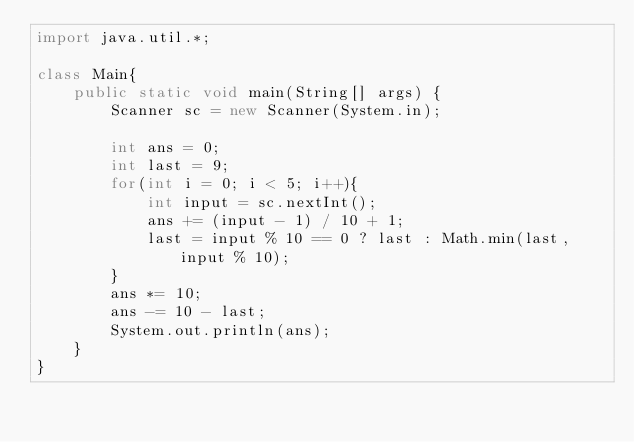Convert code to text. <code><loc_0><loc_0><loc_500><loc_500><_Java_>import java.util.*;

class Main{
    public static void main(String[] args) {
        Scanner sc = new Scanner(System.in);

        int ans = 0;
        int last = 9;
        for(int i = 0; i < 5; i++){
            int input = sc.nextInt();
            ans += (input - 1) / 10 + 1;
            last = input % 10 == 0 ? last : Math.min(last, input % 10);
        }
        ans *= 10;
        ans -= 10 - last;
        System.out.println(ans);
    }
}</code> 